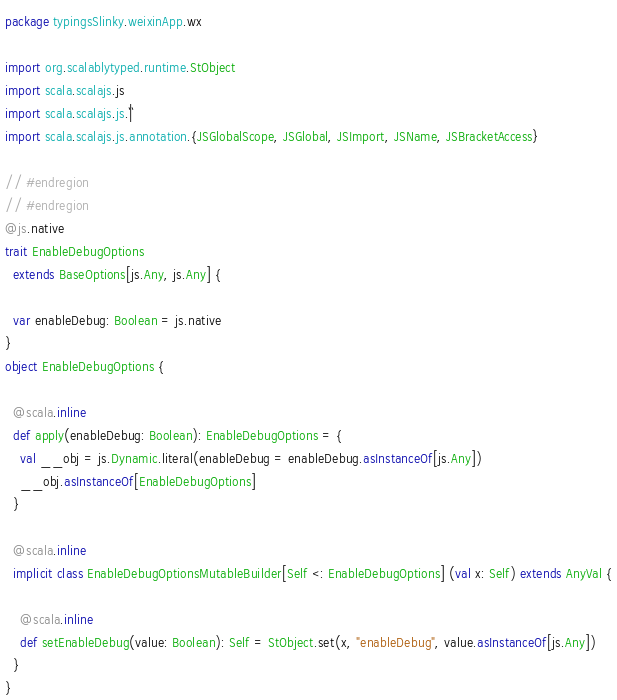<code> <loc_0><loc_0><loc_500><loc_500><_Scala_>package typingsSlinky.weixinApp.wx

import org.scalablytyped.runtime.StObject
import scala.scalajs.js
import scala.scalajs.js.`|`
import scala.scalajs.js.annotation.{JSGlobalScope, JSGlobal, JSImport, JSName, JSBracketAccess}

// #endregion
// #endregion
@js.native
trait EnableDebugOptions
  extends BaseOptions[js.Any, js.Any] {
  
  var enableDebug: Boolean = js.native
}
object EnableDebugOptions {
  
  @scala.inline
  def apply(enableDebug: Boolean): EnableDebugOptions = {
    val __obj = js.Dynamic.literal(enableDebug = enableDebug.asInstanceOf[js.Any])
    __obj.asInstanceOf[EnableDebugOptions]
  }
  
  @scala.inline
  implicit class EnableDebugOptionsMutableBuilder[Self <: EnableDebugOptions] (val x: Self) extends AnyVal {
    
    @scala.inline
    def setEnableDebug(value: Boolean): Self = StObject.set(x, "enableDebug", value.asInstanceOf[js.Any])
  }
}
</code> 